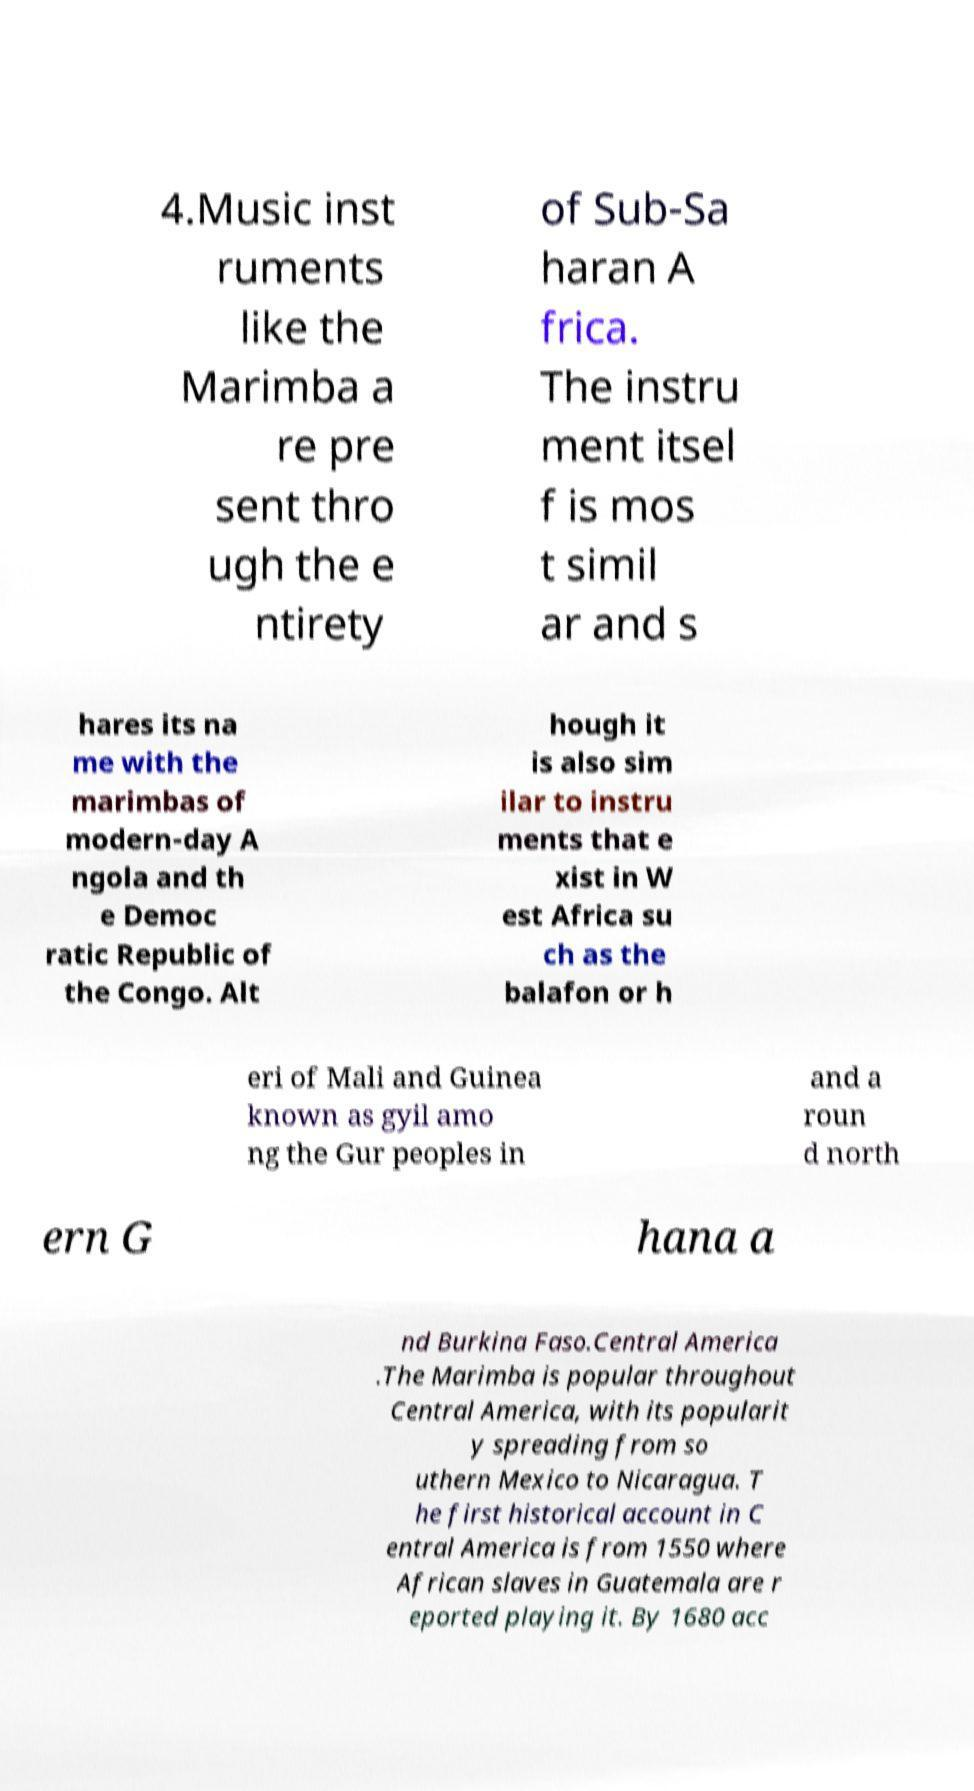Please read and relay the text visible in this image. What does it say? 4.Music inst ruments like the Marimba a re pre sent thro ugh the e ntirety of Sub-Sa haran A frica. The instru ment itsel f is mos t simil ar and s hares its na me with the marimbas of modern-day A ngola and th e Democ ratic Republic of the Congo. Alt hough it is also sim ilar to instru ments that e xist in W est Africa su ch as the balafon or h eri of Mali and Guinea known as gyil amo ng the Gur peoples in and a roun d north ern G hana a nd Burkina Faso.Central America .The Marimba is popular throughout Central America, with its popularit y spreading from so uthern Mexico to Nicaragua. T he first historical account in C entral America is from 1550 where African slaves in Guatemala are r eported playing it. By 1680 acc 